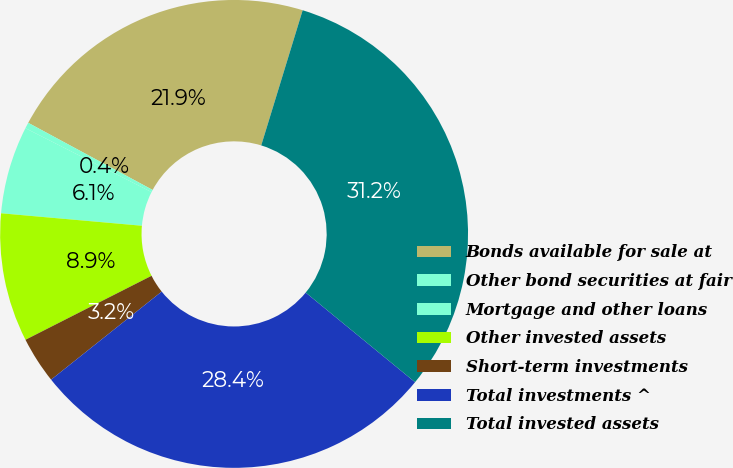<chart> <loc_0><loc_0><loc_500><loc_500><pie_chart><fcel>Bonds available for sale at<fcel>Other bond securities at fair<fcel>Mortgage and other loans<fcel>Other invested assets<fcel>Short-term investments<fcel>Total investments ^<fcel>Total invested assets<nl><fcel>21.86%<fcel>0.41%<fcel>6.06%<fcel>8.88%<fcel>3.23%<fcel>28.37%<fcel>31.19%<nl></chart> 